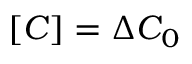Convert formula to latex. <formula><loc_0><loc_0><loc_500><loc_500>[ C ] = \Delta C _ { 0 }</formula> 